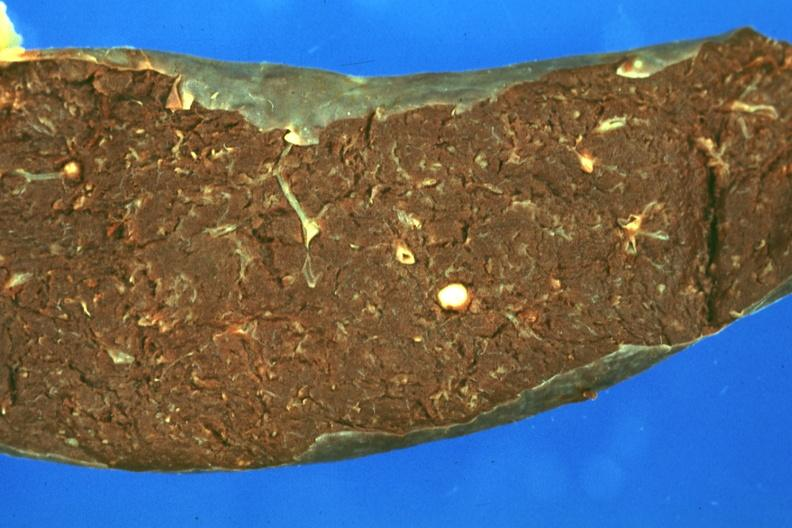does yellow color show fixed tissue but color not too bad single typical lesion?
Answer the question using a single word or phrase. No 